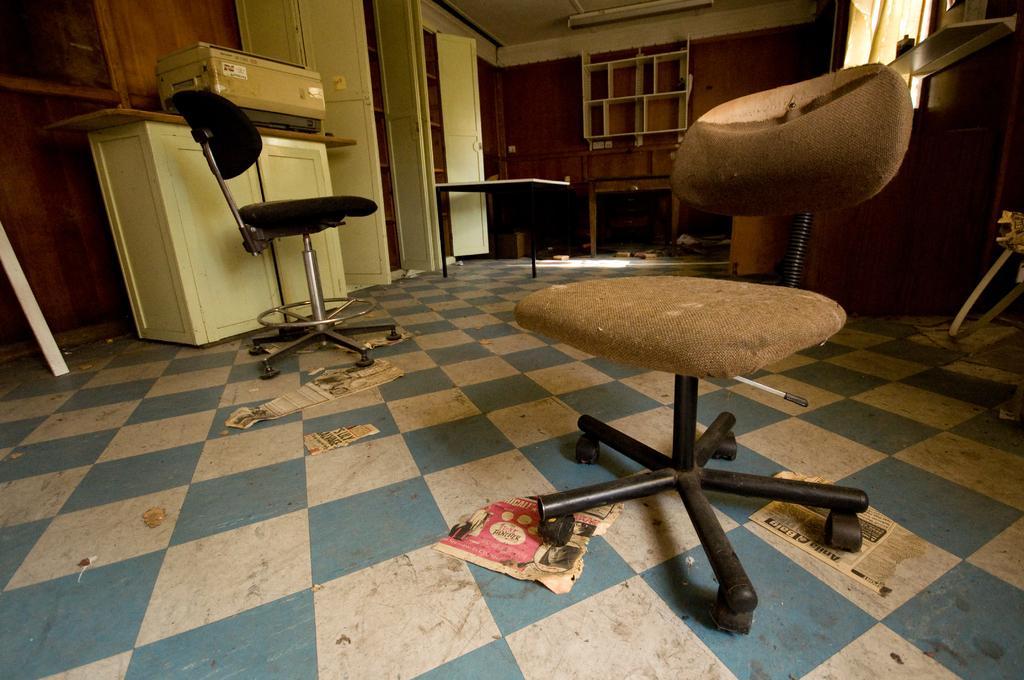Can you describe this image briefly? These are the two chairs on the floor and there are other things in this room. 